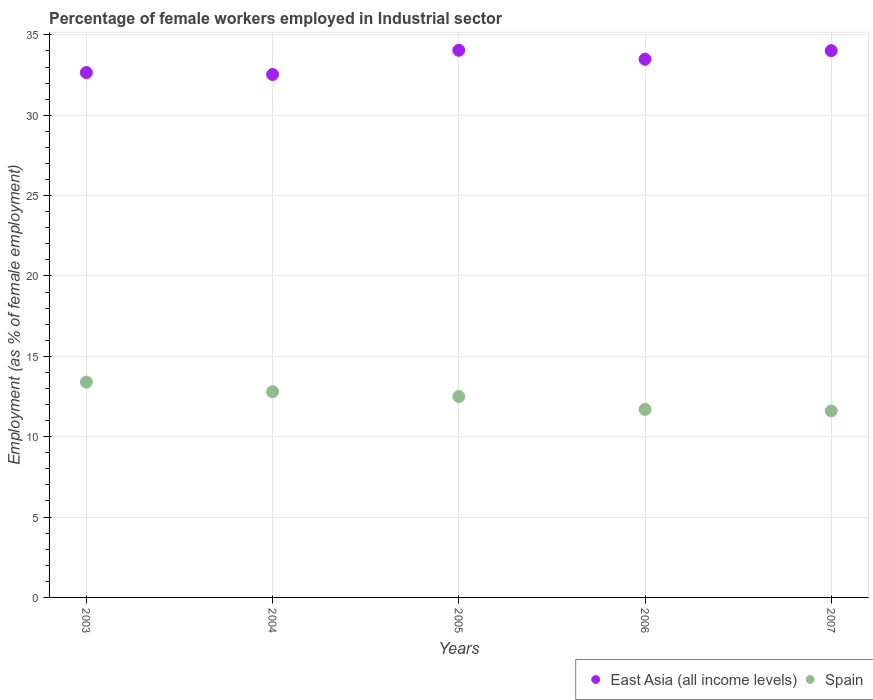What is the percentage of females employed in Industrial sector in East Asia (all income levels) in 2005?
Ensure brevity in your answer.  34.04. Across all years, what is the maximum percentage of females employed in Industrial sector in Spain?
Provide a short and direct response. 13.4. Across all years, what is the minimum percentage of females employed in Industrial sector in Spain?
Provide a succinct answer. 11.6. In which year was the percentage of females employed in Industrial sector in Spain maximum?
Ensure brevity in your answer.  2003. In which year was the percentage of females employed in Industrial sector in Spain minimum?
Provide a succinct answer. 2007. What is the difference between the percentage of females employed in Industrial sector in East Asia (all income levels) in 2004 and that in 2006?
Keep it short and to the point. -0.95. What is the difference between the percentage of females employed in Industrial sector in Spain in 2006 and the percentage of females employed in Industrial sector in East Asia (all income levels) in 2007?
Your answer should be compact. -22.32. What is the average percentage of females employed in Industrial sector in Spain per year?
Keep it short and to the point. 12.4. In the year 2005, what is the difference between the percentage of females employed in Industrial sector in East Asia (all income levels) and percentage of females employed in Industrial sector in Spain?
Your answer should be compact. 21.54. In how many years, is the percentage of females employed in Industrial sector in Spain greater than 29 %?
Give a very brief answer. 0. What is the ratio of the percentage of females employed in Industrial sector in East Asia (all income levels) in 2003 to that in 2006?
Provide a succinct answer. 0.98. What is the difference between the highest and the second highest percentage of females employed in Industrial sector in East Asia (all income levels)?
Offer a terse response. 0.02. What is the difference between the highest and the lowest percentage of females employed in Industrial sector in East Asia (all income levels)?
Provide a short and direct response. 1.51. In how many years, is the percentage of females employed in Industrial sector in East Asia (all income levels) greater than the average percentage of females employed in Industrial sector in East Asia (all income levels) taken over all years?
Make the answer very short. 3. Is the sum of the percentage of females employed in Industrial sector in Spain in 2005 and 2007 greater than the maximum percentage of females employed in Industrial sector in East Asia (all income levels) across all years?
Ensure brevity in your answer.  No. Is the percentage of females employed in Industrial sector in East Asia (all income levels) strictly greater than the percentage of females employed in Industrial sector in Spain over the years?
Your answer should be very brief. Yes. Is the percentage of females employed in Industrial sector in East Asia (all income levels) strictly less than the percentage of females employed in Industrial sector in Spain over the years?
Offer a very short reply. No. How many years are there in the graph?
Offer a terse response. 5. What is the difference between two consecutive major ticks on the Y-axis?
Your response must be concise. 5. Does the graph contain any zero values?
Make the answer very short. No. Does the graph contain grids?
Keep it short and to the point. Yes. Where does the legend appear in the graph?
Ensure brevity in your answer.  Bottom right. How are the legend labels stacked?
Offer a very short reply. Horizontal. What is the title of the graph?
Offer a terse response. Percentage of female workers employed in Industrial sector. Does "Spain" appear as one of the legend labels in the graph?
Provide a succinct answer. Yes. What is the label or title of the X-axis?
Your answer should be very brief. Years. What is the label or title of the Y-axis?
Offer a very short reply. Employment (as % of female employment). What is the Employment (as % of female employment) of East Asia (all income levels) in 2003?
Your response must be concise. 32.66. What is the Employment (as % of female employment) of Spain in 2003?
Your answer should be very brief. 13.4. What is the Employment (as % of female employment) of East Asia (all income levels) in 2004?
Provide a succinct answer. 32.54. What is the Employment (as % of female employment) in Spain in 2004?
Your answer should be compact. 12.8. What is the Employment (as % of female employment) in East Asia (all income levels) in 2005?
Your answer should be compact. 34.04. What is the Employment (as % of female employment) of Spain in 2005?
Offer a terse response. 12.5. What is the Employment (as % of female employment) of East Asia (all income levels) in 2006?
Keep it short and to the point. 33.49. What is the Employment (as % of female employment) in Spain in 2006?
Ensure brevity in your answer.  11.7. What is the Employment (as % of female employment) of East Asia (all income levels) in 2007?
Provide a short and direct response. 34.02. What is the Employment (as % of female employment) in Spain in 2007?
Your answer should be compact. 11.6. Across all years, what is the maximum Employment (as % of female employment) in East Asia (all income levels)?
Keep it short and to the point. 34.04. Across all years, what is the maximum Employment (as % of female employment) of Spain?
Provide a short and direct response. 13.4. Across all years, what is the minimum Employment (as % of female employment) of East Asia (all income levels)?
Keep it short and to the point. 32.54. Across all years, what is the minimum Employment (as % of female employment) in Spain?
Keep it short and to the point. 11.6. What is the total Employment (as % of female employment) in East Asia (all income levels) in the graph?
Provide a short and direct response. 166.74. What is the difference between the Employment (as % of female employment) of East Asia (all income levels) in 2003 and that in 2004?
Provide a succinct answer. 0.12. What is the difference between the Employment (as % of female employment) of East Asia (all income levels) in 2003 and that in 2005?
Keep it short and to the point. -1.39. What is the difference between the Employment (as % of female employment) of Spain in 2003 and that in 2005?
Give a very brief answer. 0.9. What is the difference between the Employment (as % of female employment) in East Asia (all income levels) in 2003 and that in 2006?
Make the answer very short. -0.83. What is the difference between the Employment (as % of female employment) in East Asia (all income levels) in 2003 and that in 2007?
Offer a terse response. -1.36. What is the difference between the Employment (as % of female employment) in Spain in 2003 and that in 2007?
Your answer should be compact. 1.8. What is the difference between the Employment (as % of female employment) of East Asia (all income levels) in 2004 and that in 2005?
Keep it short and to the point. -1.51. What is the difference between the Employment (as % of female employment) in Spain in 2004 and that in 2005?
Your answer should be very brief. 0.3. What is the difference between the Employment (as % of female employment) of East Asia (all income levels) in 2004 and that in 2006?
Your answer should be very brief. -0.95. What is the difference between the Employment (as % of female employment) of Spain in 2004 and that in 2006?
Your response must be concise. 1.1. What is the difference between the Employment (as % of female employment) in East Asia (all income levels) in 2004 and that in 2007?
Make the answer very short. -1.48. What is the difference between the Employment (as % of female employment) of Spain in 2004 and that in 2007?
Make the answer very short. 1.2. What is the difference between the Employment (as % of female employment) of East Asia (all income levels) in 2005 and that in 2006?
Give a very brief answer. 0.56. What is the difference between the Employment (as % of female employment) in East Asia (all income levels) in 2005 and that in 2007?
Provide a short and direct response. 0.02. What is the difference between the Employment (as % of female employment) of East Asia (all income levels) in 2006 and that in 2007?
Provide a succinct answer. -0.53. What is the difference between the Employment (as % of female employment) of East Asia (all income levels) in 2003 and the Employment (as % of female employment) of Spain in 2004?
Give a very brief answer. 19.86. What is the difference between the Employment (as % of female employment) in East Asia (all income levels) in 2003 and the Employment (as % of female employment) in Spain in 2005?
Offer a terse response. 20.16. What is the difference between the Employment (as % of female employment) in East Asia (all income levels) in 2003 and the Employment (as % of female employment) in Spain in 2006?
Keep it short and to the point. 20.96. What is the difference between the Employment (as % of female employment) in East Asia (all income levels) in 2003 and the Employment (as % of female employment) in Spain in 2007?
Give a very brief answer. 21.06. What is the difference between the Employment (as % of female employment) in East Asia (all income levels) in 2004 and the Employment (as % of female employment) in Spain in 2005?
Offer a very short reply. 20.04. What is the difference between the Employment (as % of female employment) of East Asia (all income levels) in 2004 and the Employment (as % of female employment) of Spain in 2006?
Your answer should be compact. 20.84. What is the difference between the Employment (as % of female employment) in East Asia (all income levels) in 2004 and the Employment (as % of female employment) in Spain in 2007?
Your answer should be compact. 20.94. What is the difference between the Employment (as % of female employment) of East Asia (all income levels) in 2005 and the Employment (as % of female employment) of Spain in 2006?
Offer a terse response. 22.34. What is the difference between the Employment (as % of female employment) of East Asia (all income levels) in 2005 and the Employment (as % of female employment) of Spain in 2007?
Make the answer very short. 22.44. What is the difference between the Employment (as % of female employment) in East Asia (all income levels) in 2006 and the Employment (as % of female employment) in Spain in 2007?
Your answer should be very brief. 21.89. What is the average Employment (as % of female employment) of East Asia (all income levels) per year?
Offer a terse response. 33.35. In the year 2003, what is the difference between the Employment (as % of female employment) in East Asia (all income levels) and Employment (as % of female employment) in Spain?
Offer a very short reply. 19.26. In the year 2004, what is the difference between the Employment (as % of female employment) in East Asia (all income levels) and Employment (as % of female employment) in Spain?
Ensure brevity in your answer.  19.74. In the year 2005, what is the difference between the Employment (as % of female employment) in East Asia (all income levels) and Employment (as % of female employment) in Spain?
Make the answer very short. 21.54. In the year 2006, what is the difference between the Employment (as % of female employment) in East Asia (all income levels) and Employment (as % of female employment) in Spain?
Make the answer very short. 21.79. In the year 2007, what is the difference between the Employment (as % of female employment) of East Asia (all income levels) and Employment (as % of female employment) of Spain?
Give a very brief answer. 22.42. What is the ratio of the Employment (as % of female employment) of Spain in 2003 to that in 2004?
Provide a succinct answer. 1.05. What is the ratio of the Employment (as % of female employment) in East Asia (all income levels) in 2003 to that in 2005?
Give a very brief answer. 0.96. What is the ratio of the Employment (as % of female employment) in Spain in 2003 to that in 2005?
Make the answer very short. 1.07. What is the ratio of the Employment (as % of female employment) of East Asia (all income levels) in 2003 to that in 2006?
Keep it short and to the point. 0.98. What is the ratio of the Employment (as % of female employment) of Spain in 2003 to that in 2006?
Your answer should be very brief. 1.15. What is the ratio of the Employment (as % of female employment) of East Asia (all income levels) in 2003 to that in 2007?
Offer a very short reply. 0.96. What is the ratio of the Employment (as % of female employment) of Spain in 2003 to that in 2007?
Provide a short and direct response. 1.16. What is the ratio of the Employment (as % of female employment) of East Asia (all income levels) in 2004 to that in 2005?
Provide a succinct answer. 0.96. What is the ratio of the Employment (as % of female employment) of East Asia (all income levels) in 2004 to that in 2006?
Give a very brief answer. 0.97. What is the ratio of the Employment (as % of female employment) of Spain in 2004 to that in 2006?
Make the answer very short. 1.09. What is the ratio of the Employment (as % of female employment) of East Asia (all income levels) in 2004 to that in 2007?
Offer a very short reply. 0.96. What is the ratio of the Employment (as % of female employment) in Spain in 2004 to that in 2007?
Your answer should be very brief. 1.1. What is the ratio of the Employment (as % of female employment) of East Asia (all income levels) in 2005 to that in 2006?
Ensure brevity in your answer.  1.02. What is the ratio of the Employment (as % of female employment) of Spain in 2005 to that in 2006?
Offer a very short reply. 1.07. What is the ratio of the Employment (as % of female employment) of Spain in 2005 to that in 2007?
Provide a succinct answer. 1.08. What is the ratio of the Employment (as % of female employment) in East Asia (all income levels) in 2006 to that in 2007?
Your answer should be very brief. 0.98. What is the ratio of the Employment (as % of female employment) in Spain in 2006 to that in 2007?
Make the answer very short. 1.01. What is the difference between the highest and the second highest Employment (as % of female employment) of East Asia (all income levels)?
Keep it short and to the point. 0.02. What is the difference between the highest and the second highest Employment (as % of female employment) of Spain?
Your answer should be compact. 0.6. What is the difference between the highest and the lowest Employment (as % of female employment) of East Asia (all income levels)?
Offer a very short reply. 1.51. 